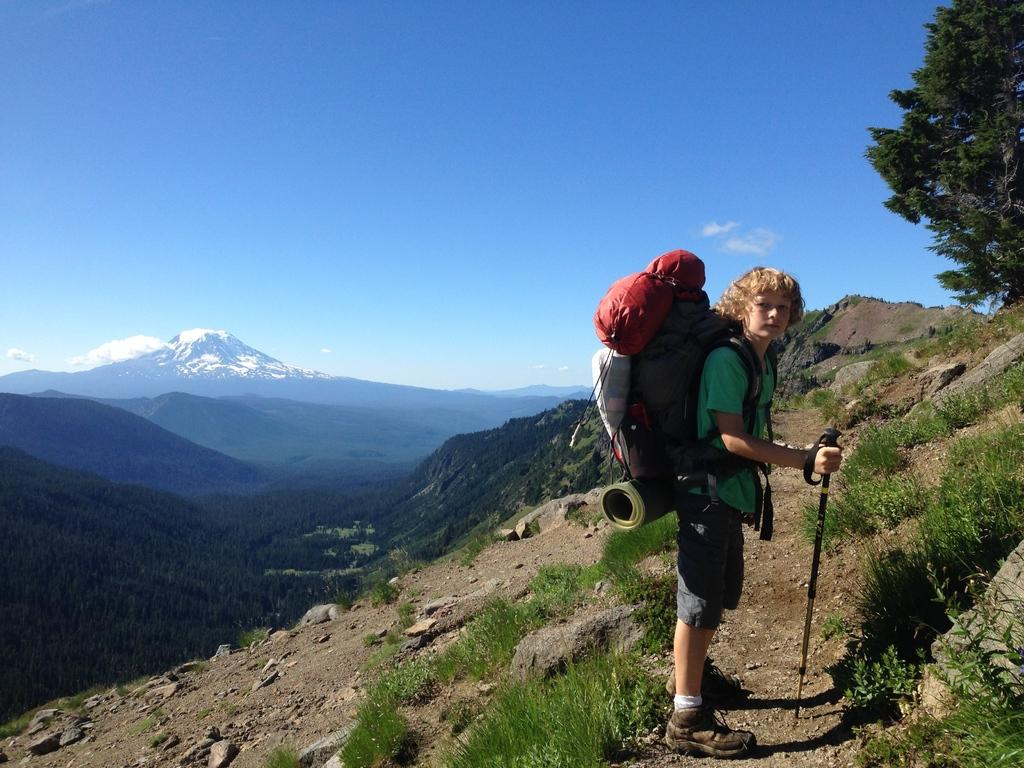Who is present in the image? There is a person in the image. What is the person carrying? The person is carrying a backpack. What type of terrain is visible in the image? There is grass and a tree in the image. What is visible in the distance in the image? There is a mountain in the background of the image. What part of the natural environment is visible in the image? The sky is visible in the image. How does the person use the hose to water the grass in the image? There is no hose present in the image, so it is not possible to answer that question. 